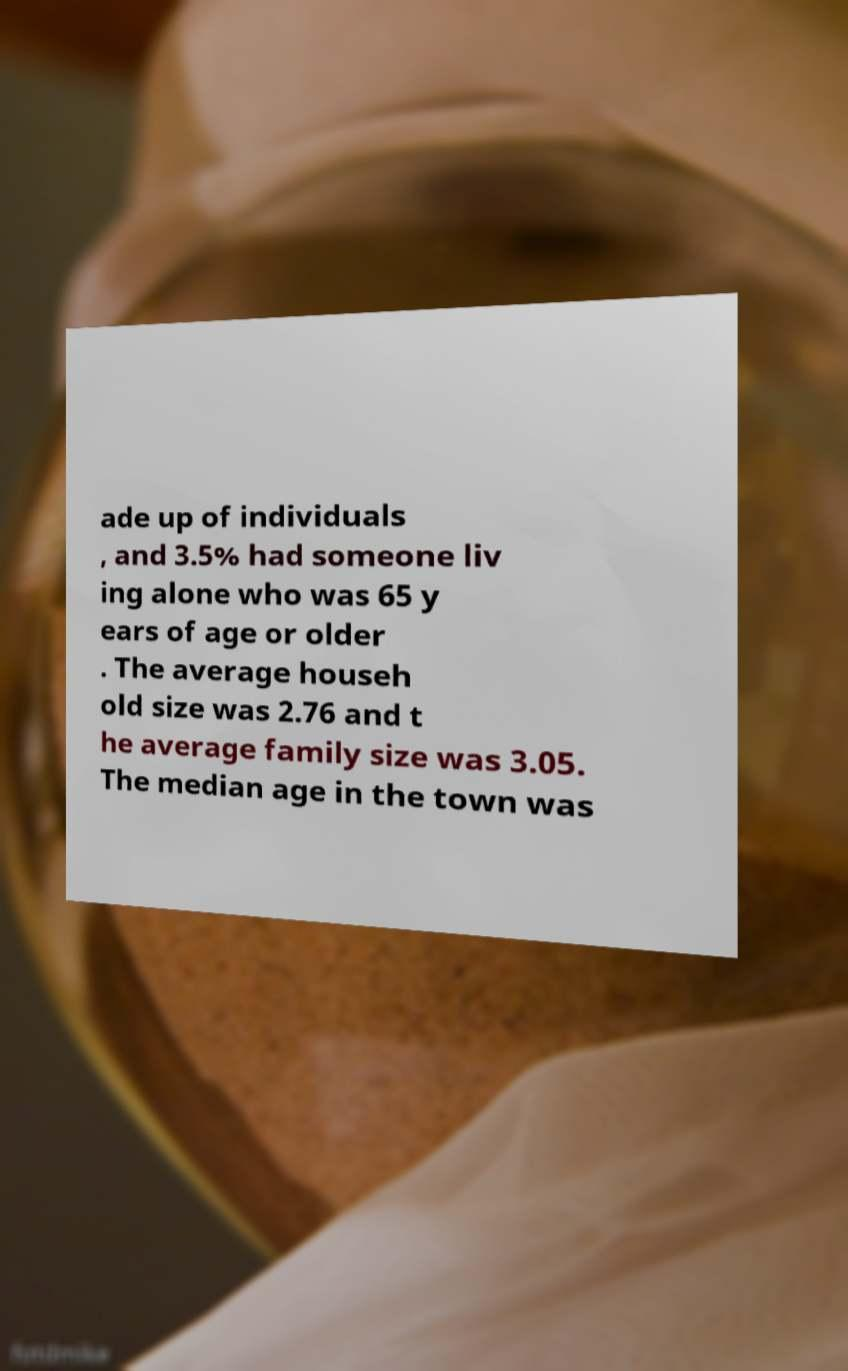There's text embedded in this image that I need extracted. Can you transcribe it verbatim? ade up of individuals , and 3.5% had someone liv ing alone who was 65 y ears of age or older . The average househ old size was 2.76 and t he average family size was 3.05. The median age in the town was 